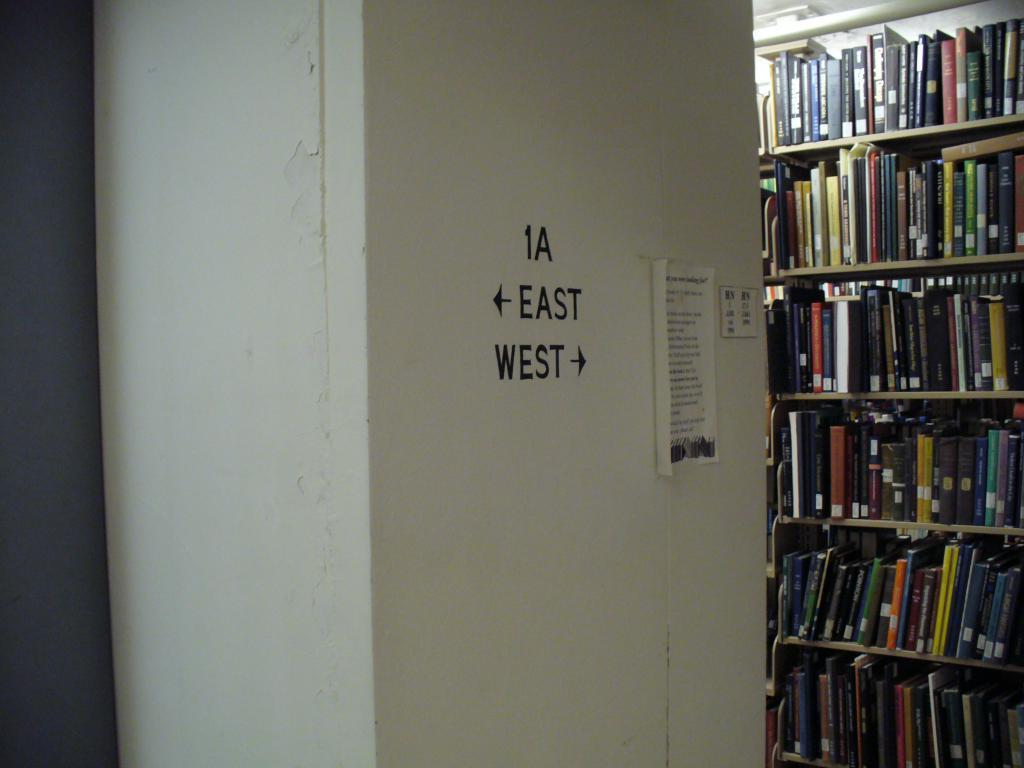<image>
Share a concise interpretation of the image provided. a library interior with directions for East and West on a pillar 